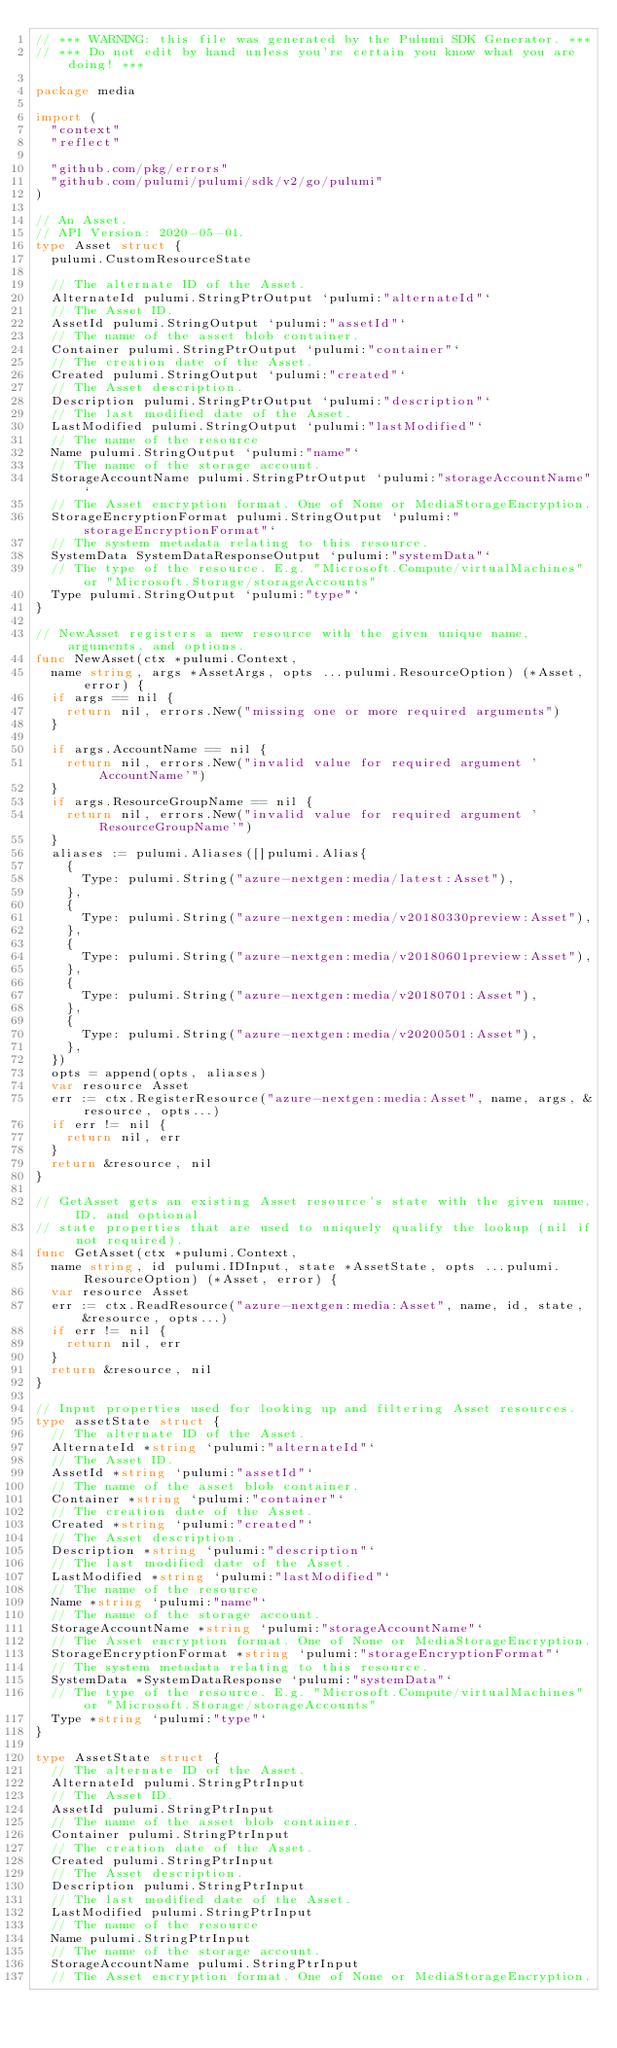Convert code to text. <code><loc_0><loc_0><loc_500><loc_500><_Go_>// *** WARNING: this file was generated by the Pulumi SDK Generator. ***
// *** Do not edit by hand unless you're certain you know what you are doing! ***

package media

import (
	"context"
	"reflect"

	"github.com/pkg/errors"
	"github.com/pulumi/pulumi/sdk/v2/go/pulumi"
)

// An Asset.
// API Version: 2020-05-01.
type Asset struct {
	pulumi.CustomResourceState

	// The alternate ID of the Asset.
	AlternateId pulumi.StringPtrOutput `pulumi:"alternateId"`
	// The Asset ID.
	AssetId pulumi.StringOutput `pulumi:"assetId"`
	// The name of the asset blob container.
	Container pulumi.StringPtrOutput `pulumi:"container"`
	// The creation date of the Asset.
	Created pulumi.StringOutput `pulumi:"created"`
	// The Asset description.
	Description pulumi.StringPtrOutput `pulumi:"description"`
	// The last modified date of the Asset.
	LastModified pulumi.StringOutput `pulumi:"lastModified"`
	// The name of the resource
	Name pulumi.StringOutput `pulumi:"name"`
	// The name of the storage account.
	StorageAccountName pulumi.StringPtrOutput `pulumi:"storageAccountName"`
	// The Asset encryption format. One of None or MediaStorageEncryption.
	StorageEncryptionFormat pulumi.StringOutput `pulumi:"storageEncryptionFormat"`
	// The system metadata relating to this resource.
	SystemData SystemDataResponseOutput `pulumi:"systemData"`
	// The type of the resource. E.g. "Microsoft.Compute/virtualMachines" or "Microsoft.Storage/storageAccounts"
	Type pulumi.StringOutput `pulumi:"type"`
}

// NewAsset registers a new resource with the given unique name, arguments, and options.
func NewAsset(ctx *pulumi.Context,
	name string, args *AssetArgs, opts ...pulumi.ResourceOption) (*Asset, error) {
	if args == nil {
		return nil, errors.New("missing one or more required arguments")
	}

	if args.AccountName == nil {
		return nil, errors.New("invalid value for required argument 'AccountName'")
	}
	if args.ResourceGroupName == nil {
		return nil, errors.New("invalid value for required argument 'ResourceGroupName'")
	}
	aliases := pulumi.Aliases([]pulumi.Alias{
		{
			Type: pulumi.String("azure-nextgen:media/latest:Asset"),
		},
		{
			Type: pulumi.String("azure-nextgen:media/v20180330preview:Asset"),
		},
		{
			Type: pulumi.String("azure-nextgen:media/v20180601preview:Asset"),
		},
		{
			Type: pulumi.String("azure-nextgen:media/v20180701:Asset"),
		},
		{
			Type: pulumi.String("azure-nextgen:media/v20200501:Asset"),
		},
	})
	opts = append(opts, aliases)
	var resource Asset
	err := ctx.RegisterResource("azure-nextgen:media:Asset", name, args, &resource, opts...)
	if err != nil {
		return nil, err
	}
	return &resource, nil
}

// GetAsset gets an existing Asset resource's state with the given name, ID, and optional
// state properties that are used to uniquely qualify the lookup (nil if not required).
func GetAsset(ctx *pulumi.Context,
	name string, id pulumi.IDInput, state *AssetState, opts ...pulumi.ResourceOption) (*Asset, error) {
	var resource Asset
	err := ctx.ReadResource("azure-nextgen:media:Asset", name, id, state, &resource, opts...)
	if err != nil {
		return nil, err
	}
	return &resource, nil
}

// Input properties used for looking up and filtering Asset resources.
type assetState struct {
	// The alternate ID of the Asset.
	AlternateId *string `pulumi:"alternateId"`
	// The Asset ID.
	AssetId *string `pulumi:"assetId"`
	// The name of the asset blob container.
	Container *string `pulumi:"container"`
	// The creation date of the Asset.
	Created *string `pulumi:"created"`
	// The Asset description.
	Description *string `pulumi:"description"`
	// The last modified date of the Asset.
	LastModified *string `pulumi:"lastModified"`
	// The name of the resource
	Name *string `pulumi:"name"`
	// The name of the storage account.
	StorageAccountName *string `pulumi:"storageAccountName"`
	// The Asset encryption format. One of None or MediaStorageEncryption.
	StorageEncryptionFormat *string `pulumi:"storageEncryptionFormat"`
	// The system metadata relating to this resource.
	SystemData *SystemDataResponse `pulumi:"systemData"`
	// The type of the resource. E.g. "Microsoft.Compute/virtualMachines" or "Microsoft.Storage/storageAccounts"
	Type *string `pulumi:"type"`
}

type AssetState struct {
	// The alternate ID of the Asset.
	AlternateId pulumi.StringPtrInput
	// The Asset ID.
	AssetId pulumi.StringPtrInput
	// The name of the asset blob container.
	Container pulumi.StringPtrInput
	// The creation date of the Asset.
	Created pulumi.StringPtrInput
	// The Asset description.
	Description pulumi.StringPtrInput
	// The last modified date of the Asset.
	LastModified pulumi.StringPtrInput
	// The name of the resource
	Name pulumi.StringPtrInput
	// The name of the storage account.
	StorageAccountName pulumi.StringPtrInput
	// The Asset encryption format. One of None or MediaStorageEncryption.</code> 